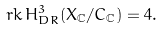<formula> <loc_0><loc_0><loc_500><loc_500>r k \, H ^ { 3 } _ { D R } ( X _ { \mathbb { C } } / C _ { \mathbb { C } } ) = 4 .</formula> 